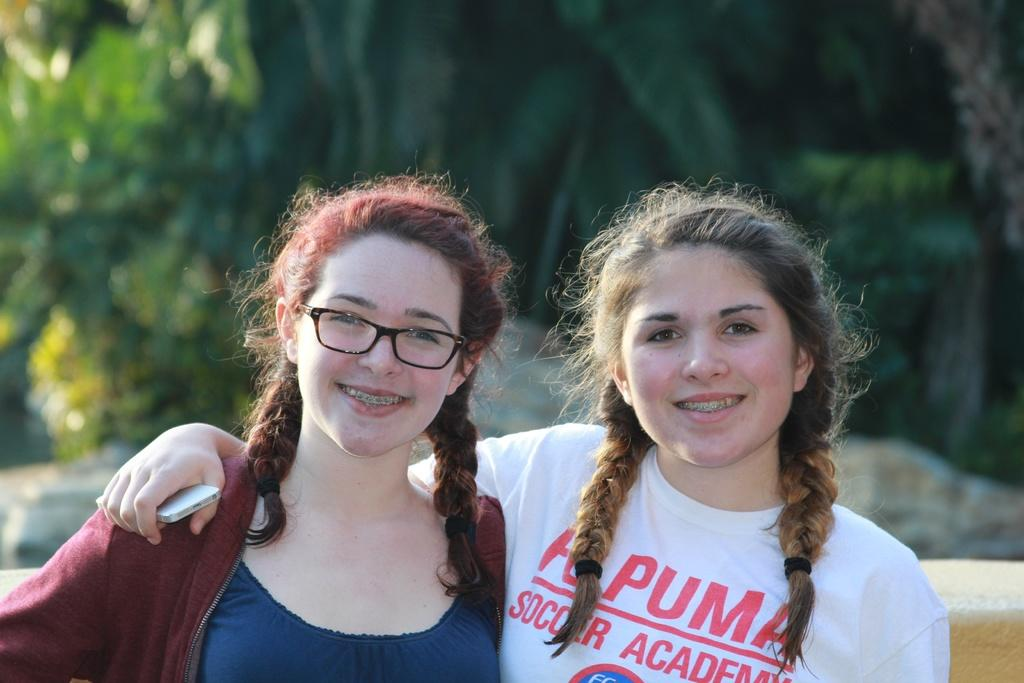How many people are in the image? There are two women in the image. What is the facial expression of the women? Both women are smiling. What is one woman holding in the image? One woman is holding a mobile. What can be seen on the face of the other woman? The other woman is wearing spectacles. Can you describe the background of the image? The background of the image is blurred. What type of worm can be seen crawling on the women's faces in the image? There are no worms present in the image; both women have clear faces. What is the condition of the day depicted in the image? The provided facts do not mention the condition of the day, so it cannot be determined from the image. 